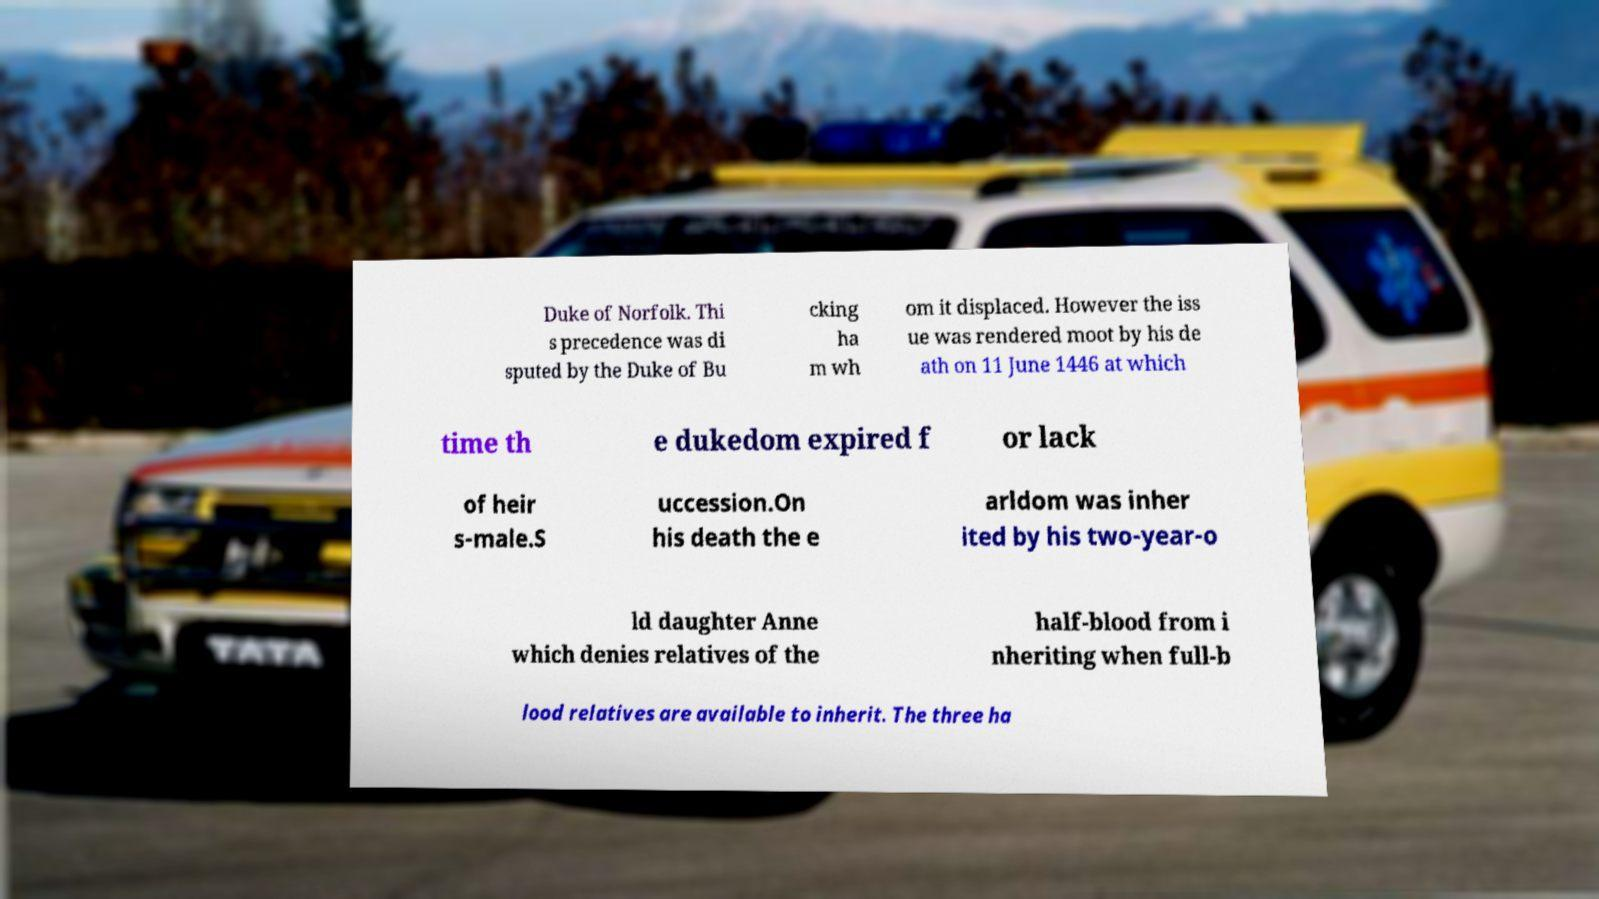Please identify and transcribe the text found in this image. Duke of Norfolk. Thi s precedence was di sputed by the Duke of Bu cking ha m wh om it displaced. However the iss ue was rendered moot by his de ath on 11 June 1446 at which time th e dukedom expired f or lack of heir s-male.S uccession.On his death the e arldom was inher ited by his two-year-o ld daughter Anne which denies relatives of the half-blood from i nheriting when full-b lood relatives are available to inherit. The three ha 